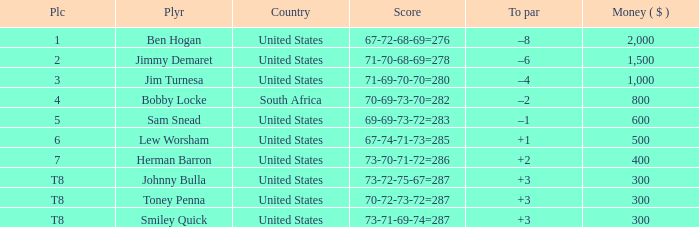What is the To par of the Player with a Score of 73-70-71-72=286? 2.0. I'm looking to parse the entire table for insights. Could you assist me with that? {'header': ['Plc', 'Plyr', 'Country', 'Score', 'To par', 'Money ( $ )'], 'rows': [['1', 'Ben Hogan', 'United States', '67-72-68-69=276', '–8', '2,000'], ['2', 'Jimmy Demaret', 'United States', '71-70-68-69=278', '–6', '1,500'], ['3', 'Jim Turnesa', 'United States', '71-69-70-70=280', '–4', '1,000'], ['4', 'Bobby Locke', 'South Africa', '70-69-73-70=282', '–2', '800'], ['5', 'Sam Snead', 'United States', '69-69-73-72=283', '–1', '600'], ['6', 'Lew Worsham', 'United States', '67-74-71-73=285', '+1', '500'], ['7', 'Herman Barron', 'United States', '73-70-71-72=286', '+2', '400'], ['T8', 'Johnny Bulla', 'United States', '73-72-75-67=287', '+3', '300'], ['T8', 'Toney Penna', 'United States', '70-72-73-72=287', '+3', '300'], ['T8', 'Smiley Quick', 'United States', '73-71-69-74=287', '+3', '300']]} 